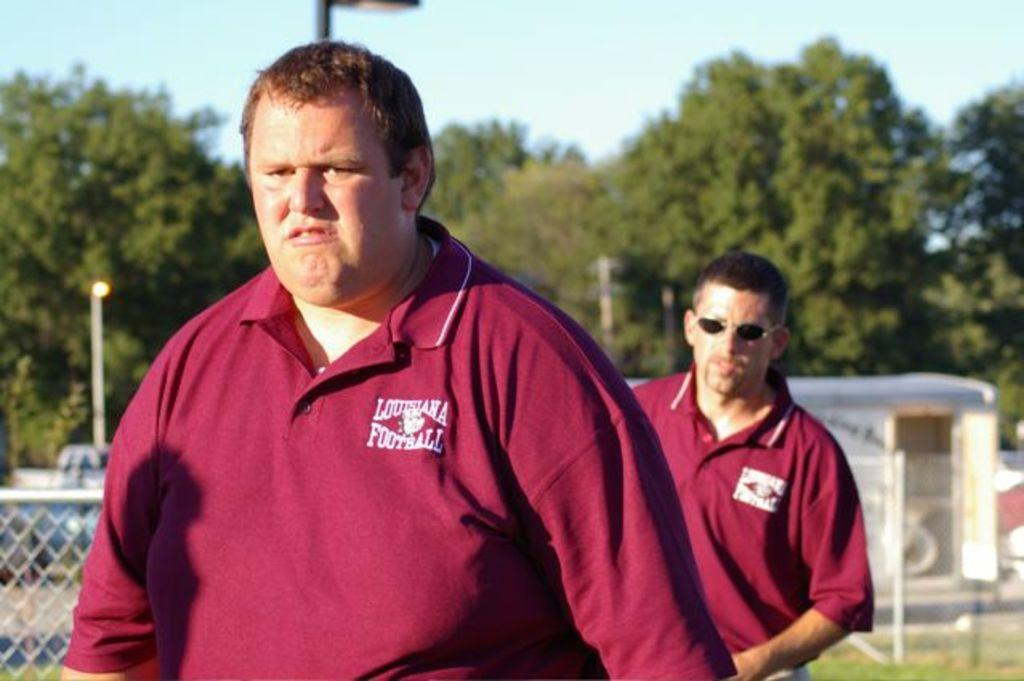<image>
Describe the image concisely. Two men wearing Louisiana Football shirts are walking on a field. 